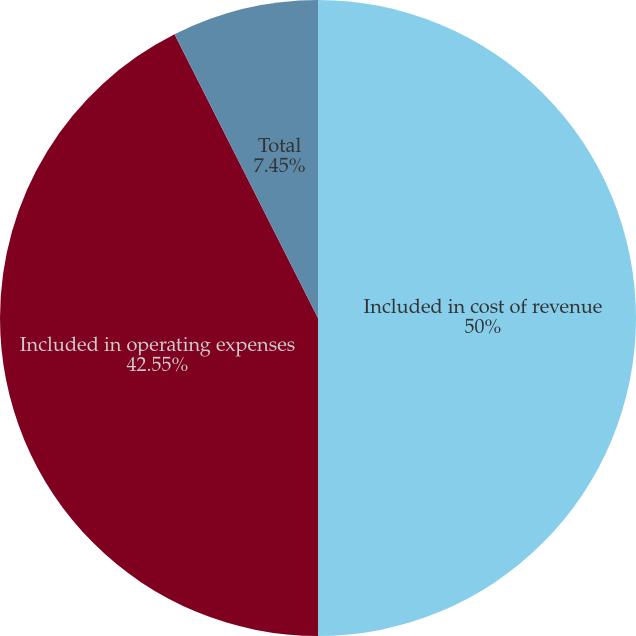<chart> <loc_0><loc_0><loc_500><loc_500><pie_chart><fcel>Included in cost of revenue<fcel>Included in operating expenses<fcel>Total<nl><fcel>50.0%<fcel>42.55%<fcel>7.45%<nl></chart> 